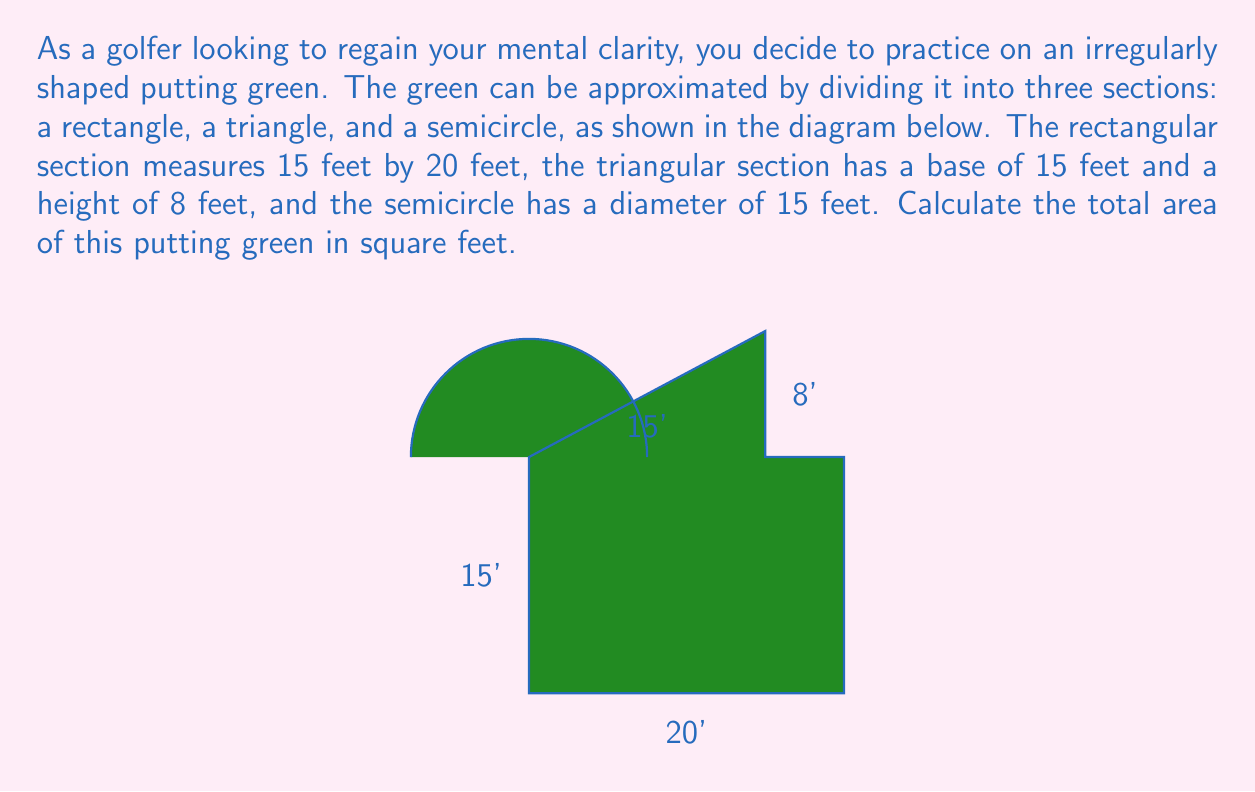Teach me how to tackle this problem. Let's break this down step-by-step:

1) First, we need to calculate the area of each section separately.

2) For the rectangular section:
   Area of rectangle = length × width
   $A_r = 20 \times 15 = 300$ sq ft

3) For the triangular section:
   Area of triangle = $\frac{1}{2} \times$ base × height
   $A_t = \frac{1}{2} \times 15 \times 8 = 60$ sq ft

4) For the semicircular section:
   Area of a semicircle = $\frac{1}{2} \times \pi r^2$
   The radius is half the diameter, so $r = 7.5$ ft
   $A_s = \frac{1}{2} \times \pi \times 7.5^2 \approx 88.36$ sq ft

5) Now, we sum up all these areas:
   Total Area = $A_r + A_t + A_s$
   $= 300 + 60 + 88.36$
   $= 448.36$ sq ft

6) Rounding to the nearest square foot:
   Total Area ≈ 448 sq ft
Answer: 448 sq ft 